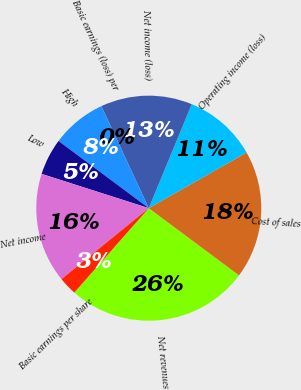<chart> <loc_0><loc_0><loc_500><loc_500><pie_chart><fcel>Net revenues<fcel>Cost of sales<fcel>Operating income (loss)<fcel>Net income (loss)<fcel>Basic earnings (loss) per<fcel>High<fcel>Low<fcel>Net income<fcel>Basic earnings per share<nl><fcel>26.32%<fcel>18.42%<fcel>10.53%<fcel>13.16%<fcel>0.0%<fcel>7.89%<fcel>5.26%<fcel>15.79%<fcel>2.63%<nl></chart> 